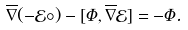Convert formula to latex. <formula><loc_0><loc_0><loc_500><loc_500>\overline { \nabla } ( - \mathcal { E } \circ ) - [ \Phi , \overline { \nabla } \mathcal { E } ] = - \Phi .</formula> 